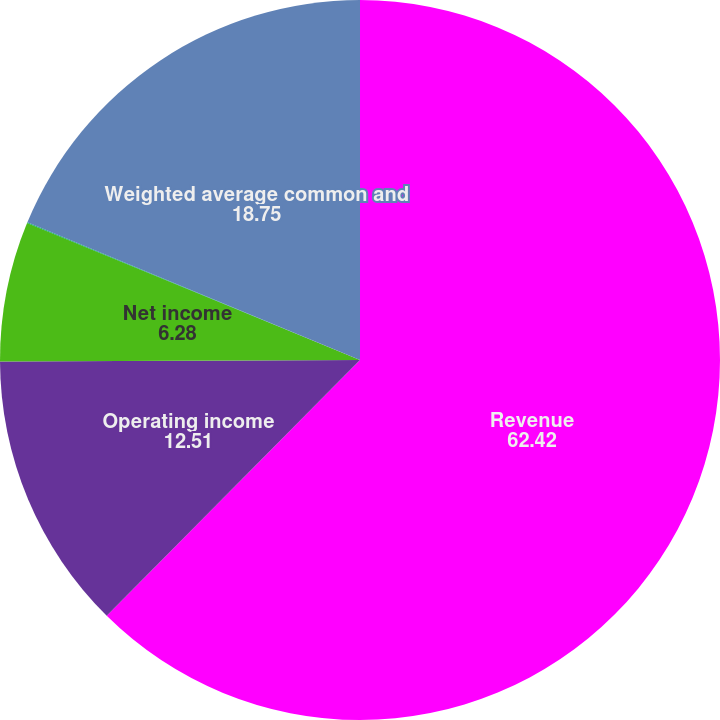<chart> <loc_0><loc_0><loc_500><loc_500><pie_chart><fcel>Revenue<fcel>Operating income<fcel>Net income<fcel>Diluted net income per share<fcel>Weighted average common and<nl><fcel>62.42%<fcel>12.51%<fcel>6.28%<fcel>0.04%<fcel>18.75%<nl></chart> 